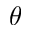Convert formula to latex. <formula><loc_0><loc_0><loc_500><loc_500>\theta</formula> 